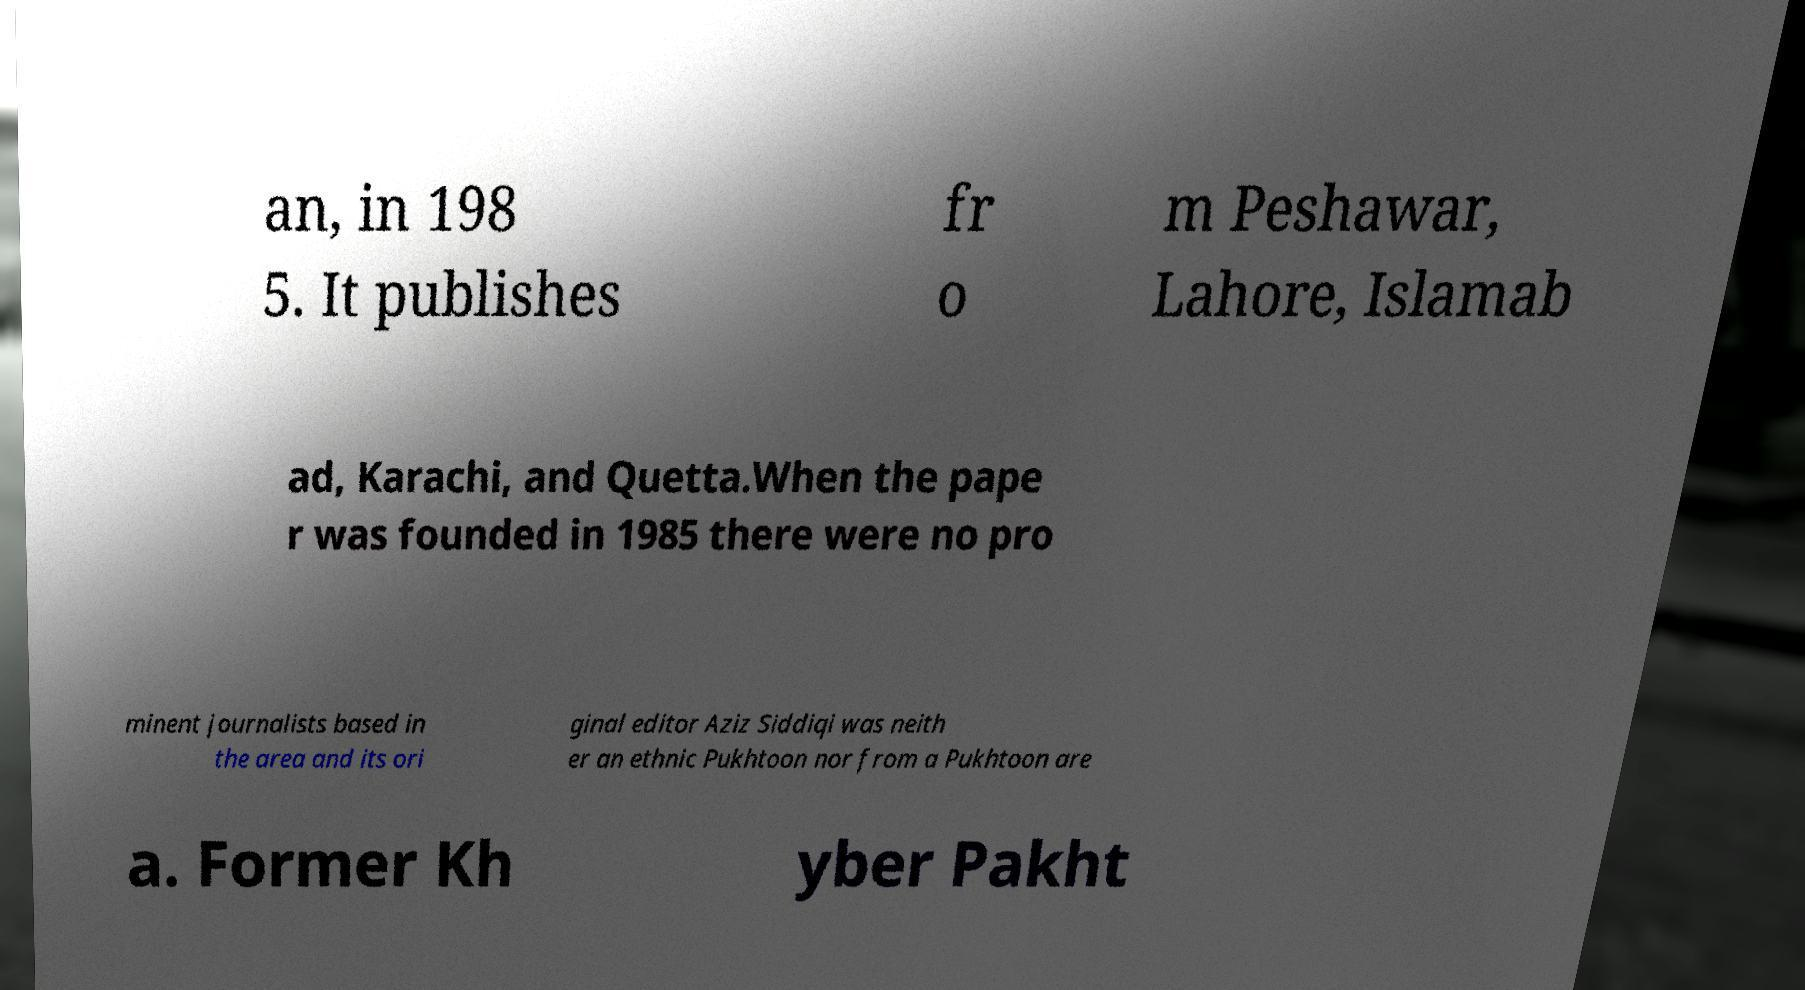Could you extract and type out the text from this image? an, in 198 5. It publishes fr o m Peshawar, Lahore, Islamab ad, Karachi, and Quetta.When the pape r was founded in 1985 there were no pro minent journalists based in the area and its ori ginal editor Aziz Siddiqi was neith er an ethnic Pukhtoon nor from a Pukhtoon are a. Former Kh yber Pakht 